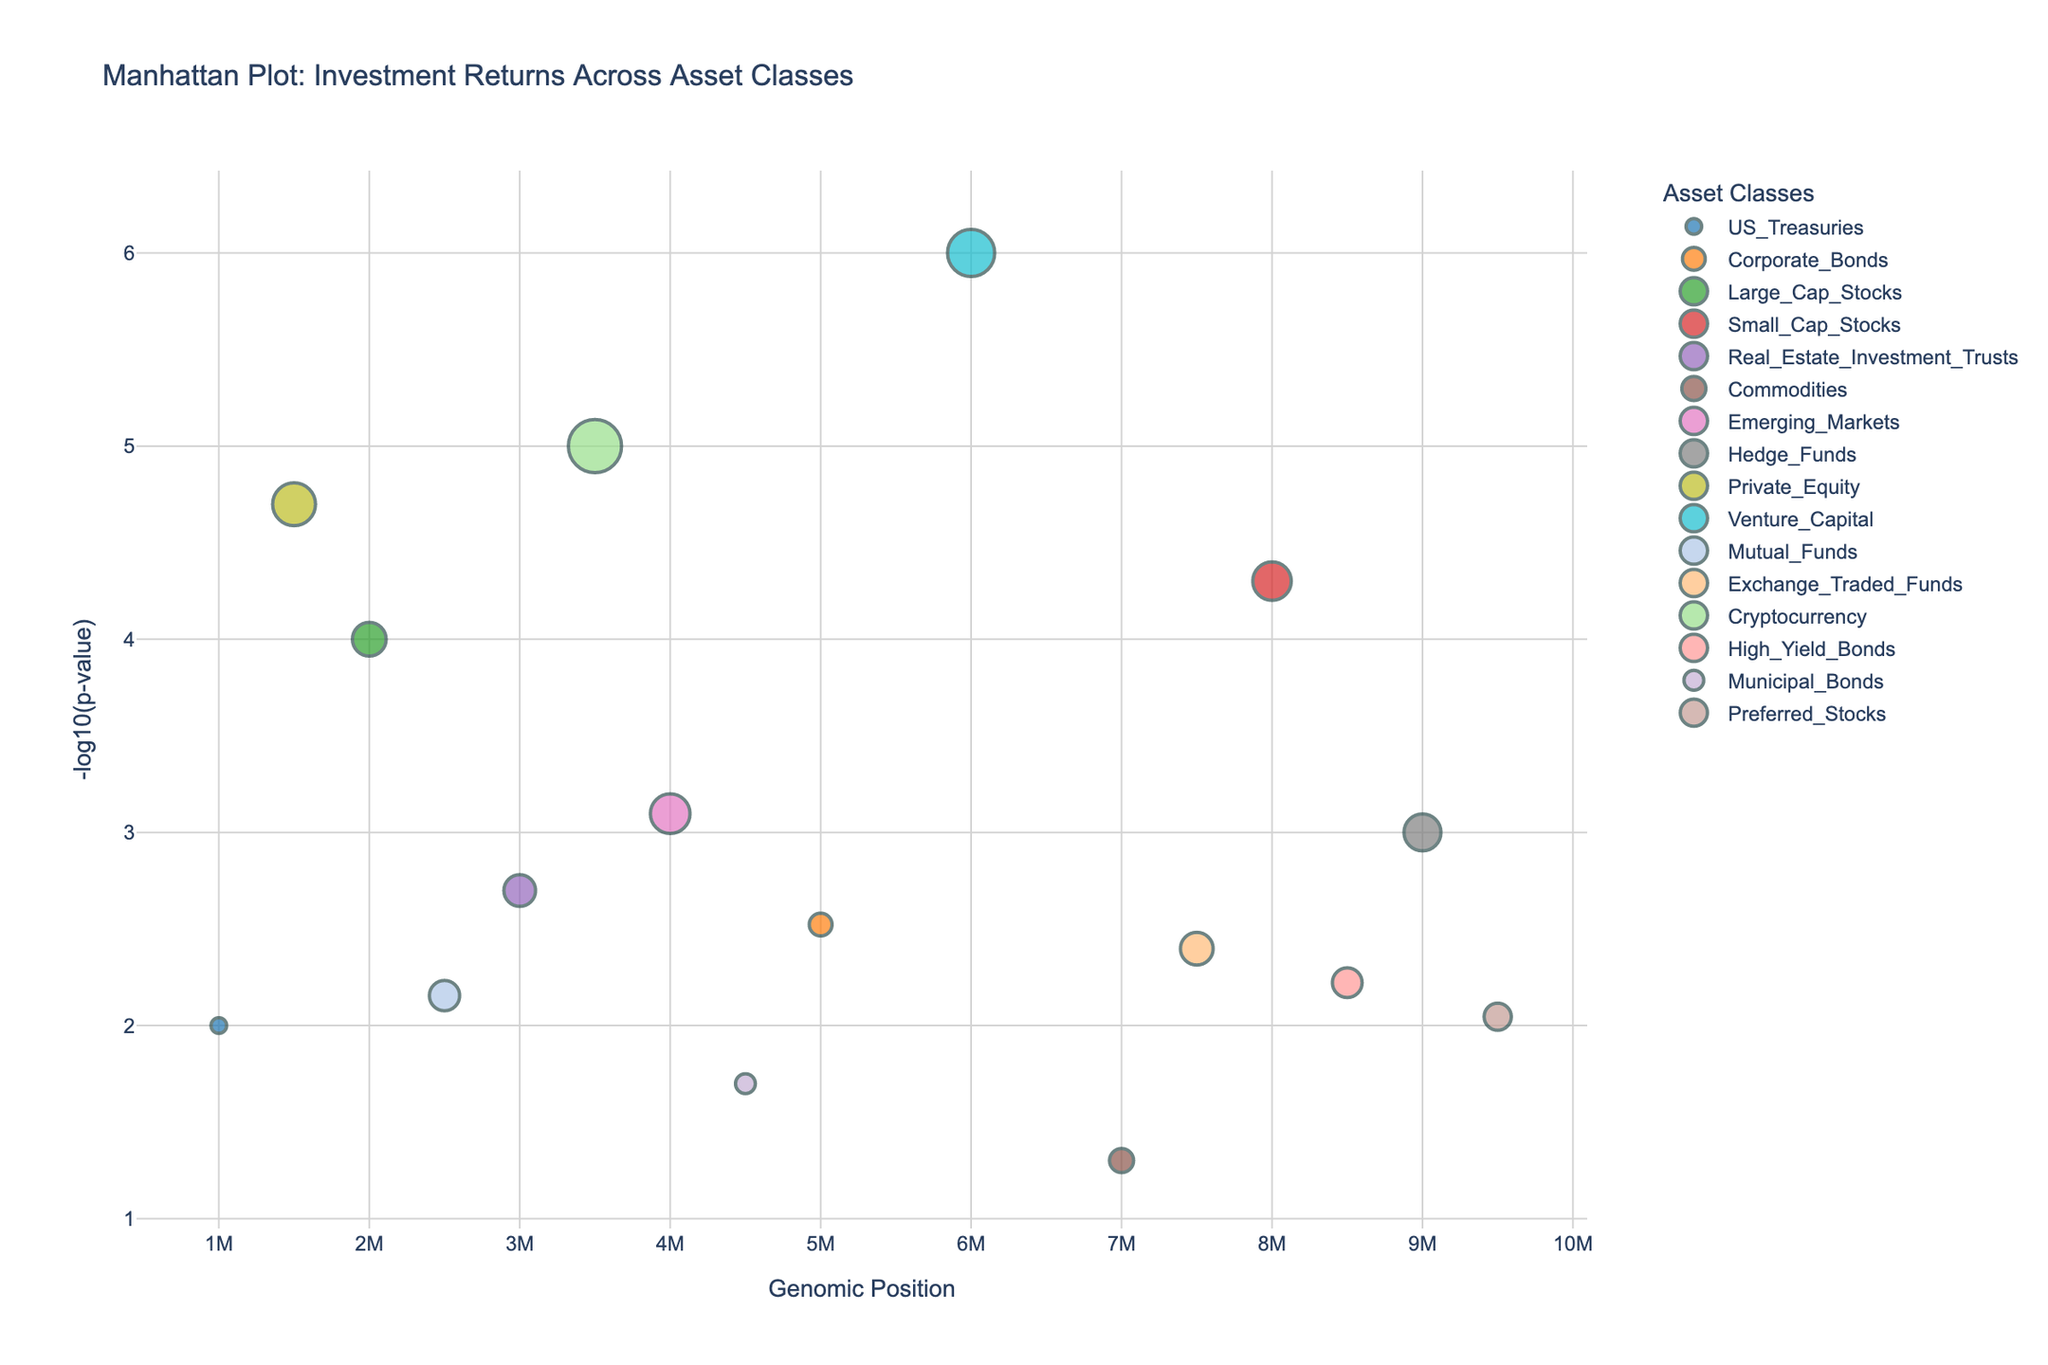What is the title of the plot? The title is usually located at the top of the figure and describes the content of the graph. In this case, it indicates the plot shows investment returns across various asset classes.
Answer: Manhattan Plot: Investment Returns Across Asset Classes How many asset classes are represented in the plot? You can identify the asset classes either from the different colored markers in the legend or by counting the unique labels along the x-axis.
Answer: 16 Which asset class has the highest annual return? By looking at the hover text or visually identifying the largest bubbles, check their y-axis value for clarity. The largest bubble corresponds to the asset class with the highest annual return.
Answer: Cryptocurrency Which asset class is associated with the most statistically significant p-value? The most statistically significant p-value will be the one with the highest -log10(p-value). Check the y-axis for the highest point.
Answer: Venture Capital What is the general trend between annual return and p-value significance? Analyze the size of the bubbles and their corresponding heights. Larger bubbles (higher annual returns) tend to be higher on the y-axis (-log10(p-value)).
Answer: Higher annual returns generally correlate with more significant p-values Compare the annual returns between 'Small Cap Stocks' and 'Large Cap Stocks'. Which has higher returns? Locate the positions of both asset classes and read their annual returns from the hover text.
Answer: Small Cap Stocks What is the genomic position of 'Emerging Markets'? Check the x-axis position correlated with the 'Emerging Markets' label on the graph.
Answer: 4,400,000 What is the annual return for 'Preferred Stocks' and how significant is its p-value compared to 'Mutual Funds'? Locate both asset classes and compare their bubble sizes and heights, with hover text providing exact values.
Answer: 4.9% (Preferred Stocks), 5.9% (Mutual Funds). Preferred Stocks has a less significant p-value How does the annual return of 'US Treasuries' compare to 'Corporate Bonds'? Locate the positions for these asset classes and check their bubble sizes and annual returns.
Answer: US Treasuries: 2.5%, Corporate Bonds: 3.8%. Corporate Bonds have higher annual returns Which asset class has the most significant p-value among 'Real Estate Investment Trusts', 'Commodities', and 'Mutual Funds'? Compare the y-axis positions (height) of these asset classes to determine which has the highest -log10(p-value).
Answer: Real Estate Investment Trusts 